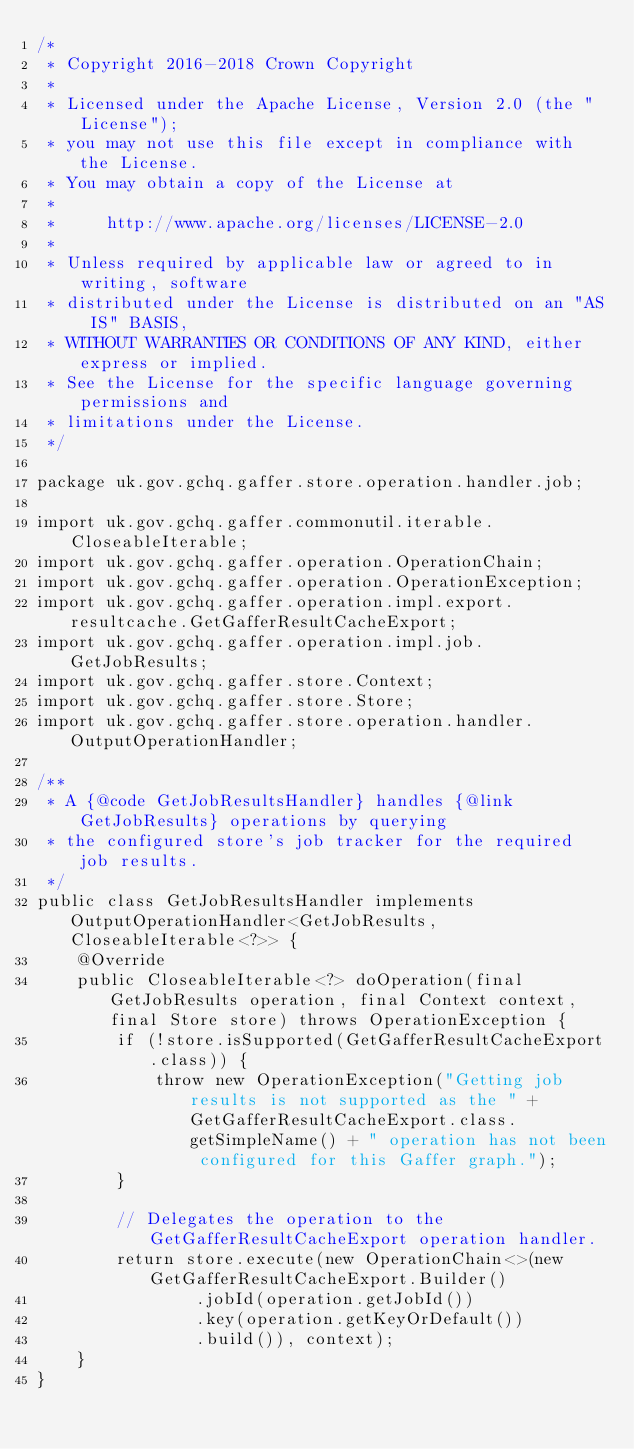<code> <loc_0><loc_0><loc_500><loc_500><_Java_>/*
 * Copyright 2016-2018 Crown Copyright
 *
 * Licensed under the Apache License, Version 2.0 (the "License");
 * you may not use this file except in compliance with the License.
 * You may obtain a copy of the License at
 *
 *     http://www.apache.org/licenses/LICENSE-2.0
 *
 * Unless required by applicable law or agreed to in writing, software
 * distributed under the License is distributed on an "AS IS" BASIS,
 * WITHOUT WARRANTIES OR CONDITIONS OF ANY KIND, either express or implied.
 * See the License for the specific language governing permissions and
 * limitations under the License.
 */

package uk.gov.gchq.gaffer.store.operation.handler.job;

import uk.gov.gchq.gaffer.commonutil.iterable.CloseableIterable;
import uk.gov.gchq.gaffer.operation.OperationChain;
import uk.gov.gchq.gaffer.operation.OperationException;
import uk.gov.gchq.gaffer.operation.impl.export.resultcache.GetGafferResultCacheExport;
import uk.gov.gchq.gaffer.operation.impl.job.GetJobResults;
import uk.gov.gchq.gaffer.store.Context;
import uk.gov.gchq.gaffer.store.Store;
import uk.gov.gchq.gaffer.store.operation.handler.OutputOperationHandler;

/**
 * A {@code GetJobResultsHandler} handles {@link GetJobResults} operations by querying
 * the configured store's job tracker for the required job results.
 */
public class GetJobResultsHandler implements OutputOperationHandler<GetJobResults, CloseableIterable<?>> {
    @Override
    public CloseableIterable<?> doOperation(final GetJobResults operation, final Context context, final Store store) throws OperationException {
        if (!store.isSupported(GetGafferResultCacheExport.class)) {
            throw new OperationException("Getting job results is not supported as the " + GetGafferResultCacheExport.class.getSimpleName() + " operation has not been configured for this Gaffer graph.");
        }

        // Delegates the operation to the GetGafferResultCacheExport operation handler.
        return store.execute(new OperationChain<>(new GetGafferResultCacheExport.Builder()
                .jobId(operation.getJobId())
                .key(operation.getKeyOrDefault())
                .build()), context);
    }
}
</code> 